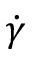Convert formula to latex. <formula><loc_0><loc_0><loc_500><loc_500>\dot { \gamma }</formula> 